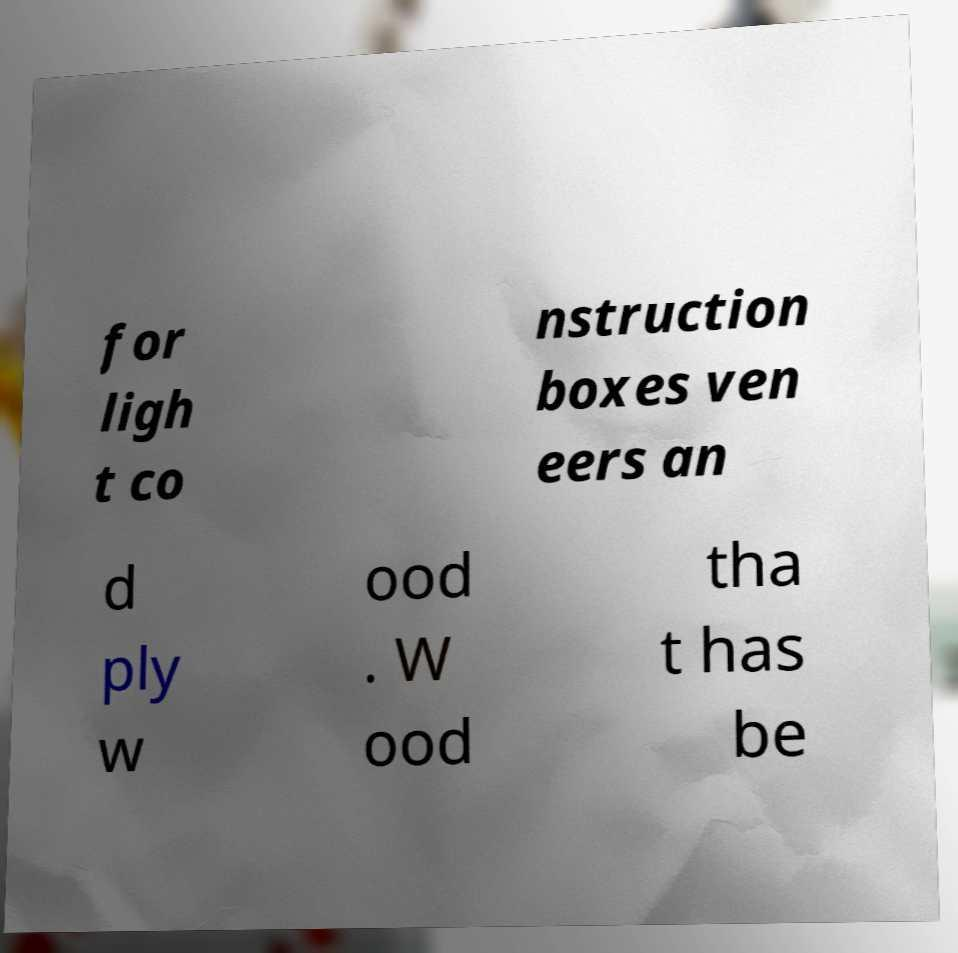There's text embedded in this image that I need extracted. Can you transcribe it verbatim? for ligh t co nstruction boxes ven eers an d ply w ood . W ood tha t has be 